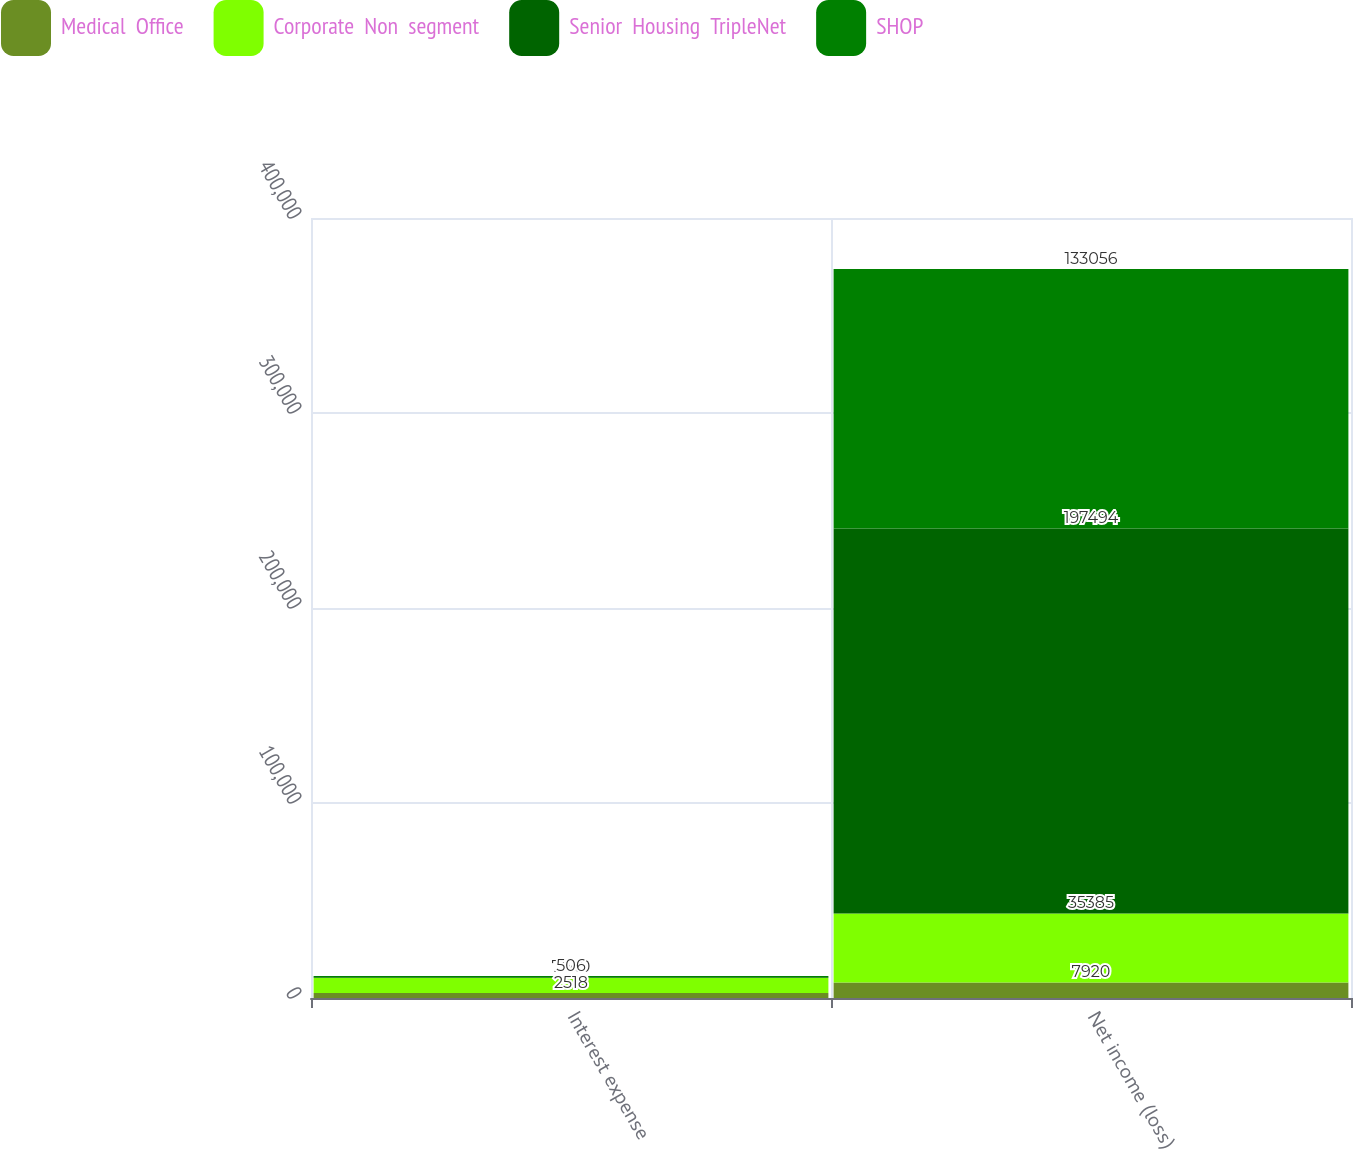Convert chart to OTSL. <chart><loc_0><loc_0><loc_500><loc_500><stacked_bar_chart><ecel><fcel>Interest expense<fcel>Net income (loss)<nl><fcel>Medical  Office<fcel>2518<fcel>7920<nl><fcel>Corporate  Non  segment<fcel>7920<fcel>35385<nl><fcel>Senior  Housing  TripleNet<fcel>373<fcel>197494<nl><fcel>SHOP<fcel>506<fcel>133056<nl></chart> 